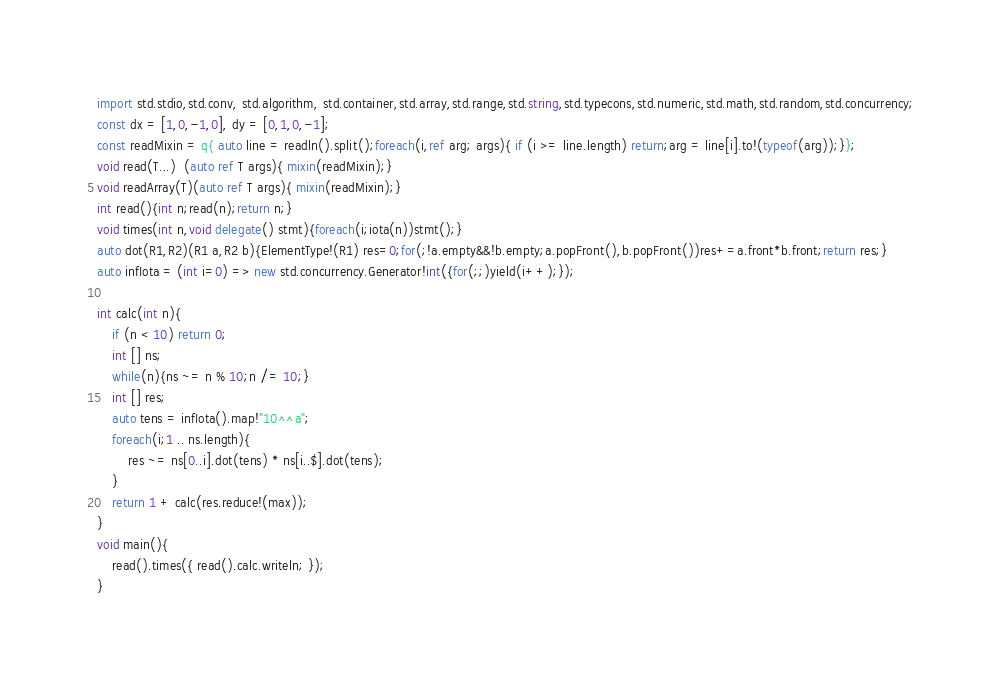Convert code to text. <code><loc_0><loc_0><loc_500><loc_500><_D_>import std.stdio,std.conv, std.algorithm, std.container,std.array,std.range,std.string,std.typecons,std.numeric,std.math,std.random,std.concurrency;
const dx = [1,0,-1,0], dy = [0,1,0,-1];
const readMixin = q{ auto line = readln().split();foreach(i,ref arg; args){ if (i >= line.length) return;arg = line[i].to!(typeof(arg));}};
void read(T...)  (auto ref T args){ mixin(readMixin);}
void readArray(T)(auto ref T args){ mixin(readMixin);}
int read(){int n;read(n);return n;}
void times(int n,void delegate() stmt){foreach(i;iota(n))stmt();}
auto dot(R1,R2)(R1 a,R2 b){ElementType!(R1) res=0;for(;!a.empty&&!b.empty;a.popFront(),b.popFront())res+=a.front*b.front;return res;}
auto infIota = (int i=0) => new std.concurrency.Generator!int({for(;;)yield(i++);});

int calc(int n){
	if (n < 10) return 0;
	int [] ns;
	while(n){ns ~= n % 10;n /= 10;}
	int [] res;
	auto tens = infIota().map!"10^^a";
	foreach(i;1 .. ns.length){
		res ~= ns[0..i].dot(tens) * ns[i..$].dot(tens);
	}
	return 1 + calc(res.reduce!(max));
}
void main(){ 
	read().times({ read().calc.writeln; });
}</code> 